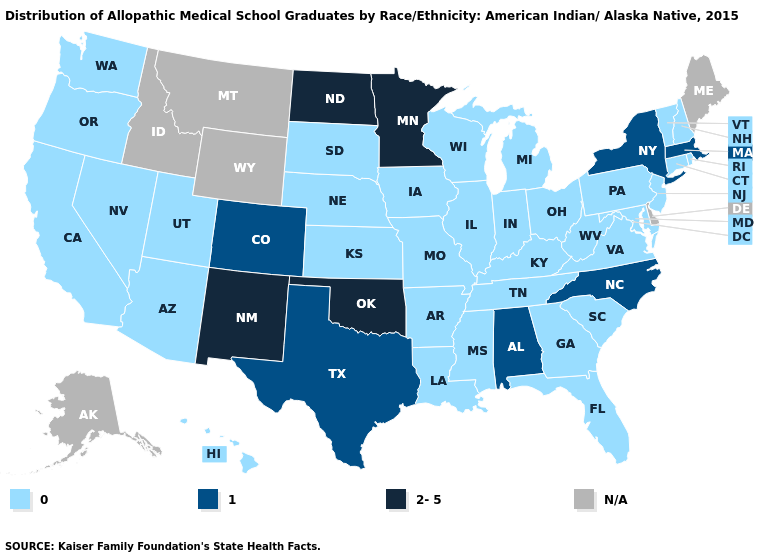What is the value of California?
Be succinct. 0. What is the lowest value in states that border Indiana?
Write a very short answer. 0. Among the states that border Georgia , which have the lowest value?
Concise answer only. Florida, South Carolina, Tennessee. What is the lowest value in the Northeast?
Short answer required. 0. Does Massachusetts have the lowest value in the USA?
Quick response, please. No. What is the value of Mississippi?
Keep it brief. 0. Name the states that have a value in the range N/A?
Concise answer only. Alaska, Delaware, Idaho, Maine, Montana, Wyoming. Does Connecticut have the highest value in the Northeast?
Write a very short answer. No. Is the legend a continuous bar?
Concise answer only. No. Which states have the lowest value in the Northeast?
Be succinct. Connecticut, New Hampshire, New Jersey, Pennsylvania, Rhode Island, Vermont. Name the states that have a value in the range 1?
Concise answer only. Alabama, Colorado, Massachusetts, New York, North Carolina, Texas. What is the lowest value in the South?
Short answer required. 0. Name the states that have a value in the range 2-5?
Give a very brief answer. Minnesota, New Mexico, North Dakota, Oklahoma. What is the highest value in the Northeast ?
Write a very short answer. 1. 